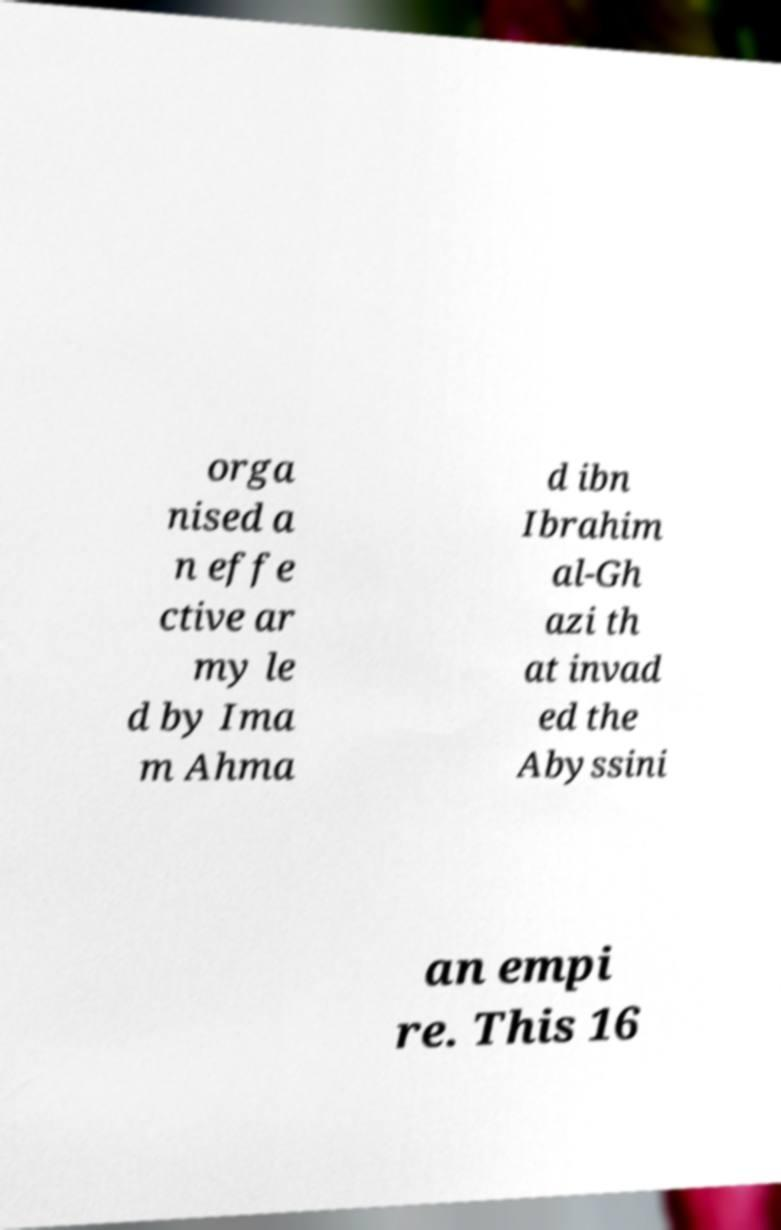Can you read and provide the text displayed in the image?This photo seems to have some interesting text. Can you extract and type it out for me? orga nised a n effe ctive ar my le d by Ima m Ahma d ibn Ibrahim al-Gh azi th at invad ed the Abyssini an empi re. This 16 